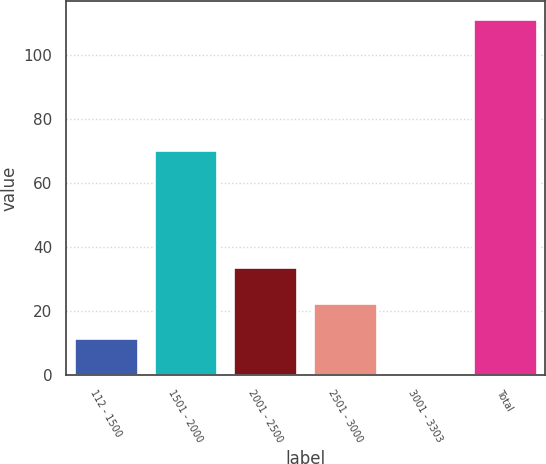Convert chart to OTSL. <chart><loc_0><loc_0><loc_500><loc_500><bar_chart><fcel>112 - 1500<fcel>1501 - 2000<fcel>2001 - 2500<fcel>2501 - 3000<fcel>3001 - 3303<fcel>Total<nl><fcel>11.42<fcel>70.4<fcel>33.66<fcel>22.54<fcel>0.3<fcel>111.5<nl></chart> 